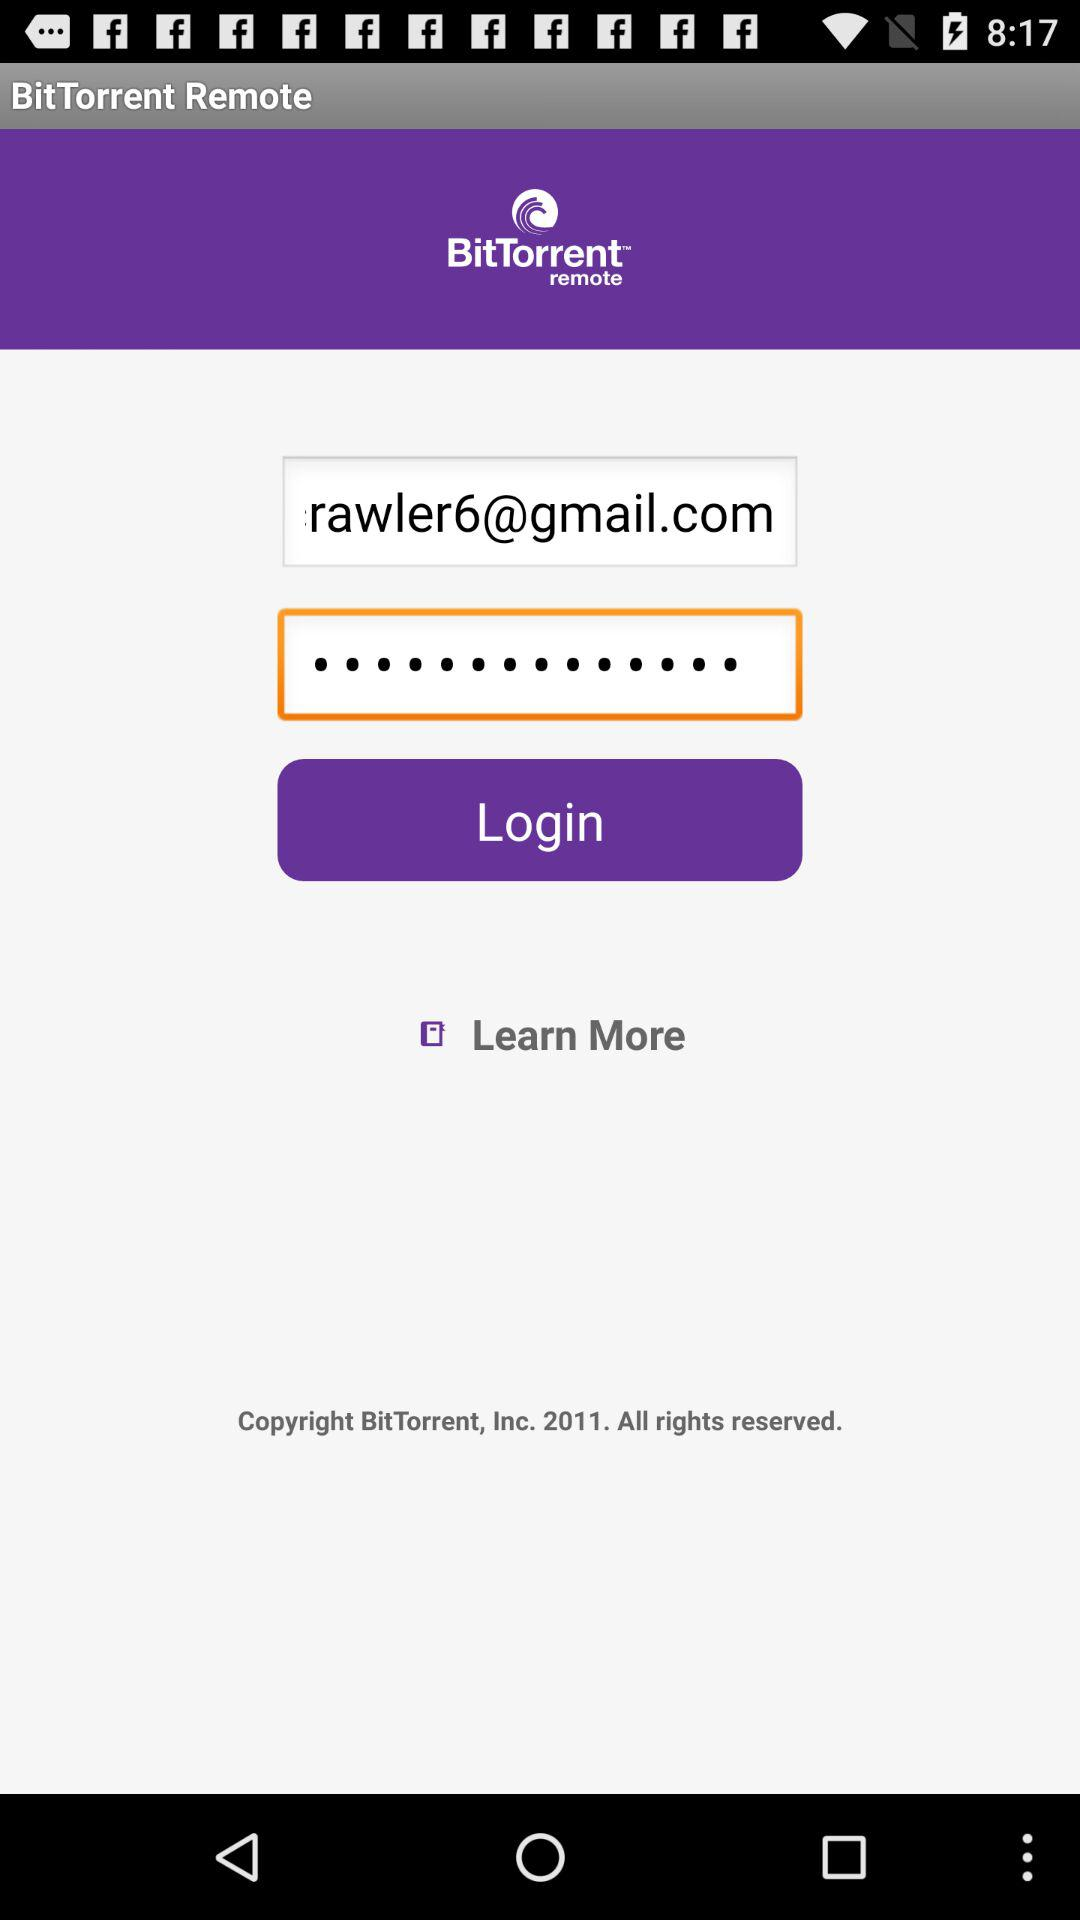What is the application name? The application name is "BitTorrent Remote". 